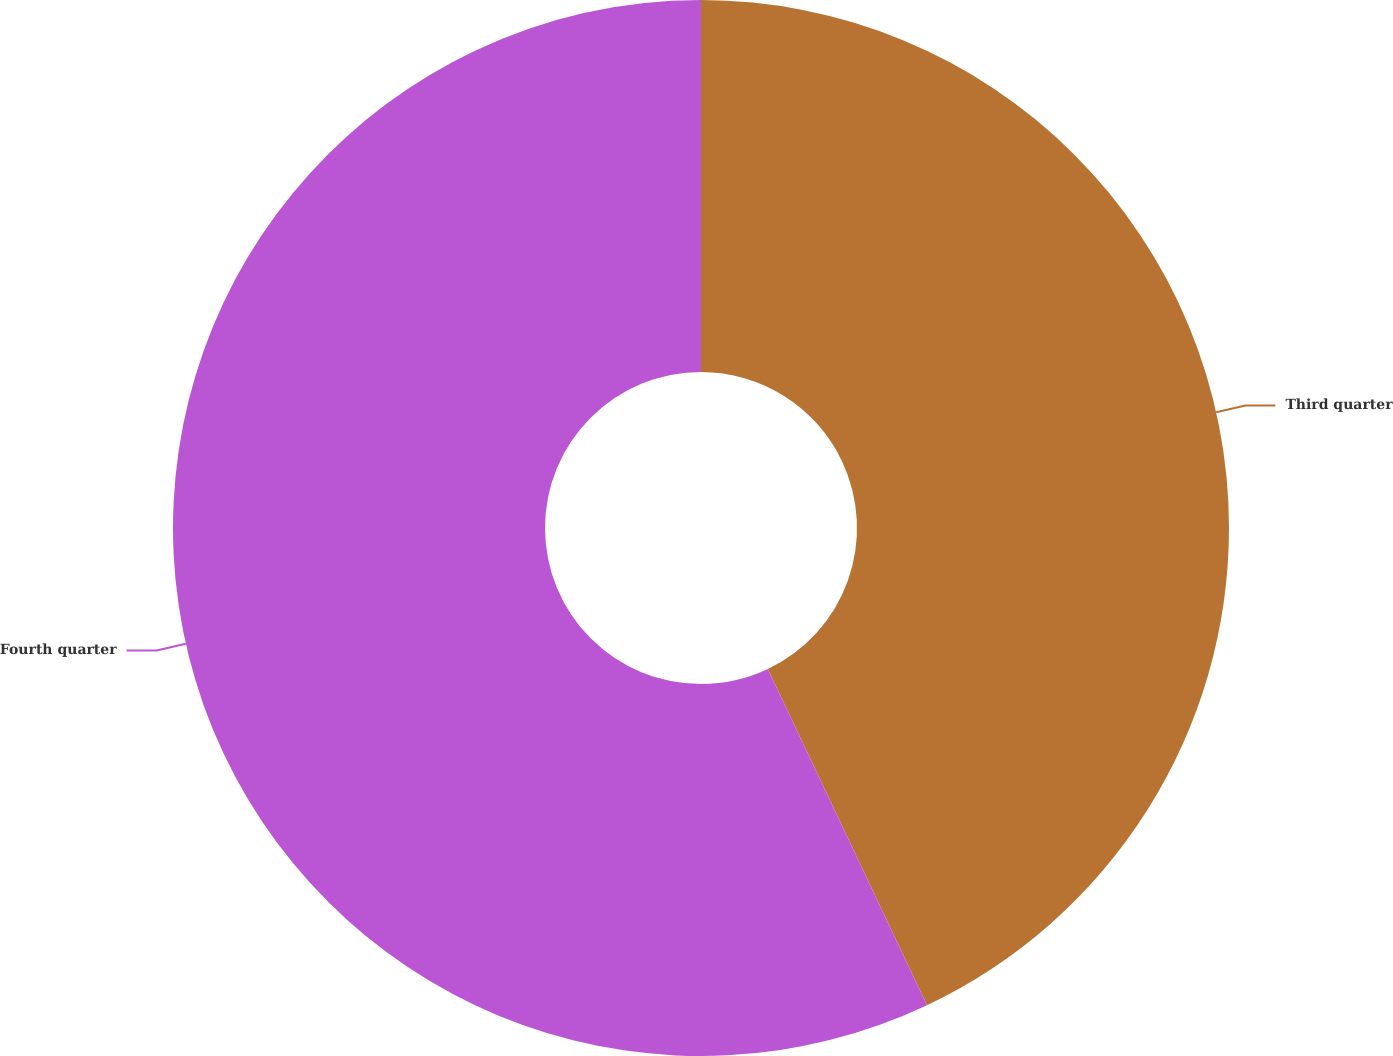Convert chart. <chart><loc_0><loc_0><loc_500><loc_500><pie_chart><fcel>Third quarter<fcel>Fourth quarter<nl><fcel>42.96%<fcel>57.04%<nl></chart> 